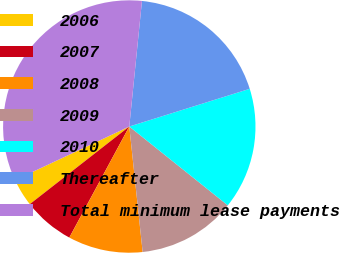<chart> <loc_0><loc_0><loc_500><loc_500><pie_chart><fcel>2006<fcel>2007<fcel>2008<fcel>2009<fcel>2010<fcel>Thereafter<fcel>Total minimum lease payments<nl><fcel>3.56%<fcel>6.57%<fcel>9.57%<fcel>12.57%<fcel>15.57%<fcel>18.57%<fcel>33.59%<nl></chart> 